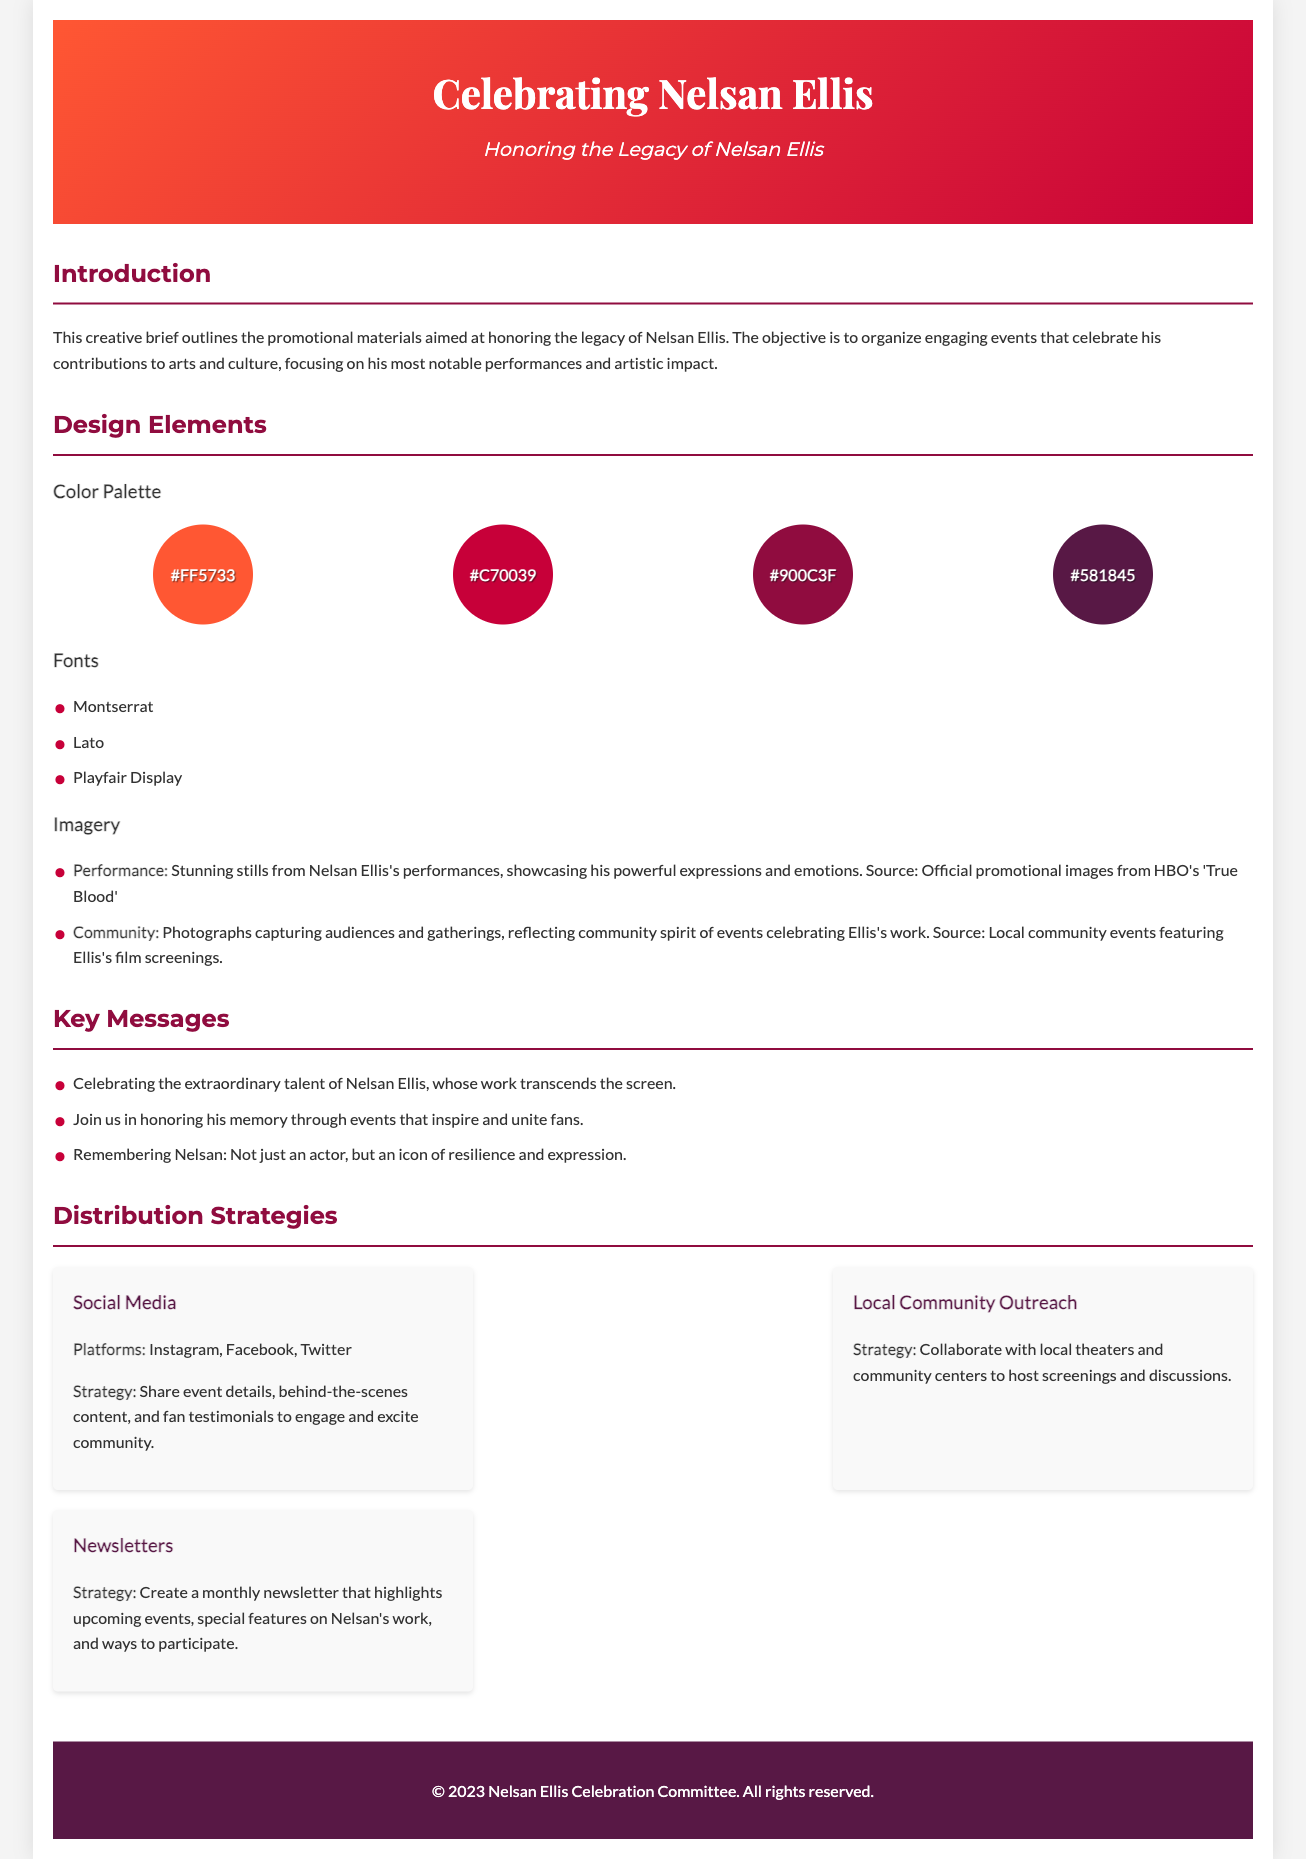What is the title of the document? The title is prominently displayed at the top of the document, celebrating Nelsan Ellis.
Answer: Celebrating Nelsan Ellis: Promotional Materials What is the tagline associated with Nelsan Ellis? The tagline is found under the title, indicating the theme of the document.
Answer: Honoring the Legacy of Nelsan Ellis How many color swatches are included in the color palette? The number of color swatches can be counted in the design elements section related to the color palette.
Answer: 4 Which font is used for headings? The font section describes the different fonts used in the document.
Answer: Playfair Display What are the social media platforms mentioned for promotions? The distribution strategies specify social media platforms for sharing event details.
Answer: Instagram, Facebook, Twitter What is the purpose of the newsletters mentioned? The document outlines newsletters as part of the distribution strategy.
Answer: Highlight upcoming events What key message indicates Nelsan Ellis's impact as an actor? One of the key messages refers to Nelsan Ellis's role and legacy as an artist.
Answer: An icon of resilience and expression What strategy is proposed for local community outreach? The local community outreach strategy is described under the distribution strategies section.
Answer: Collaborate with local theaters What is the background color of the header section? The gradient color of the header gives visual importance to the title and tagline.
Answer: Linear gradient from #FF5733 to #C70039 